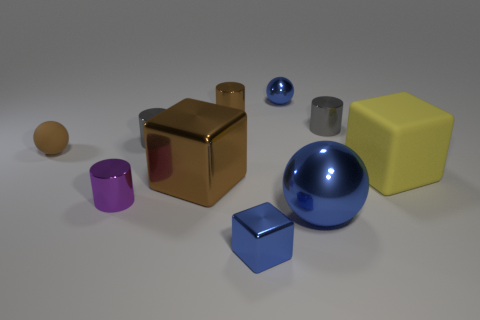Subtract all metallic blocks. How many blocks are left? 1 Subtract 2 cylinders. How many cylinders are left? 2 Subtract all brown cylinders. How many cylinders are left? 3 Subtract all large matte objects. Subtract all tiny metal blocks. How many objects are left? 8 Add 2 spheres. How many spheres are left? 5 Add 5 big metallic cubes. How many big metallic cubes exist? 6 Subtract 0 purple spheres. How many objects are left? 10 Subtract all cylinders. How many objects are left? 6 Subtract all blue balls. Subtract all blue cubes. How many balls are left? 1 Subtract all blue balls. How many yellow blocks are left? 1 